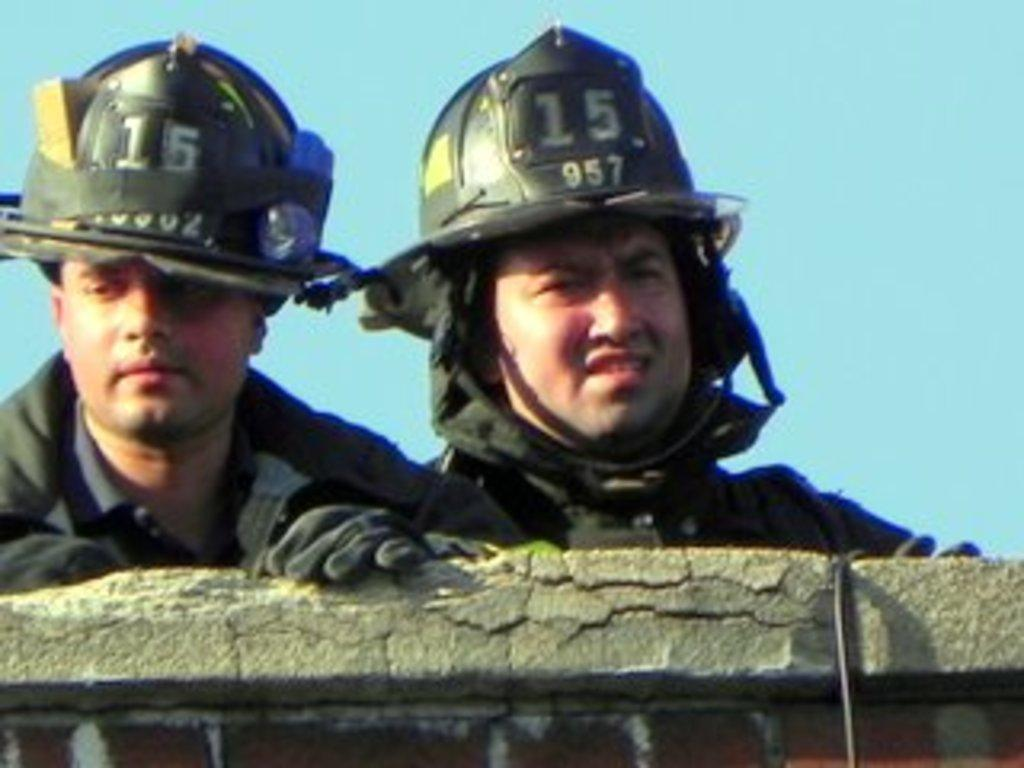How many people are in the image? There are two men in the image. What are the men wearing on their heads? The men are wearing helmets. What type of clothing are the men wearing on their upper bodies? The men are wearing jackets. What are the men wearing on their hands? The men are wearing gloves. What is at the bottom of the image? There is a wall at the bottom of the image. What can be seen in the background of the image? The sky is visible in the background of the image. What type of plant is growing on the wall in the image? There is no plant growing on the wall in the image. How many birds are in the flock flying over the men in the image? There are no birds or flocks visible in the image. 